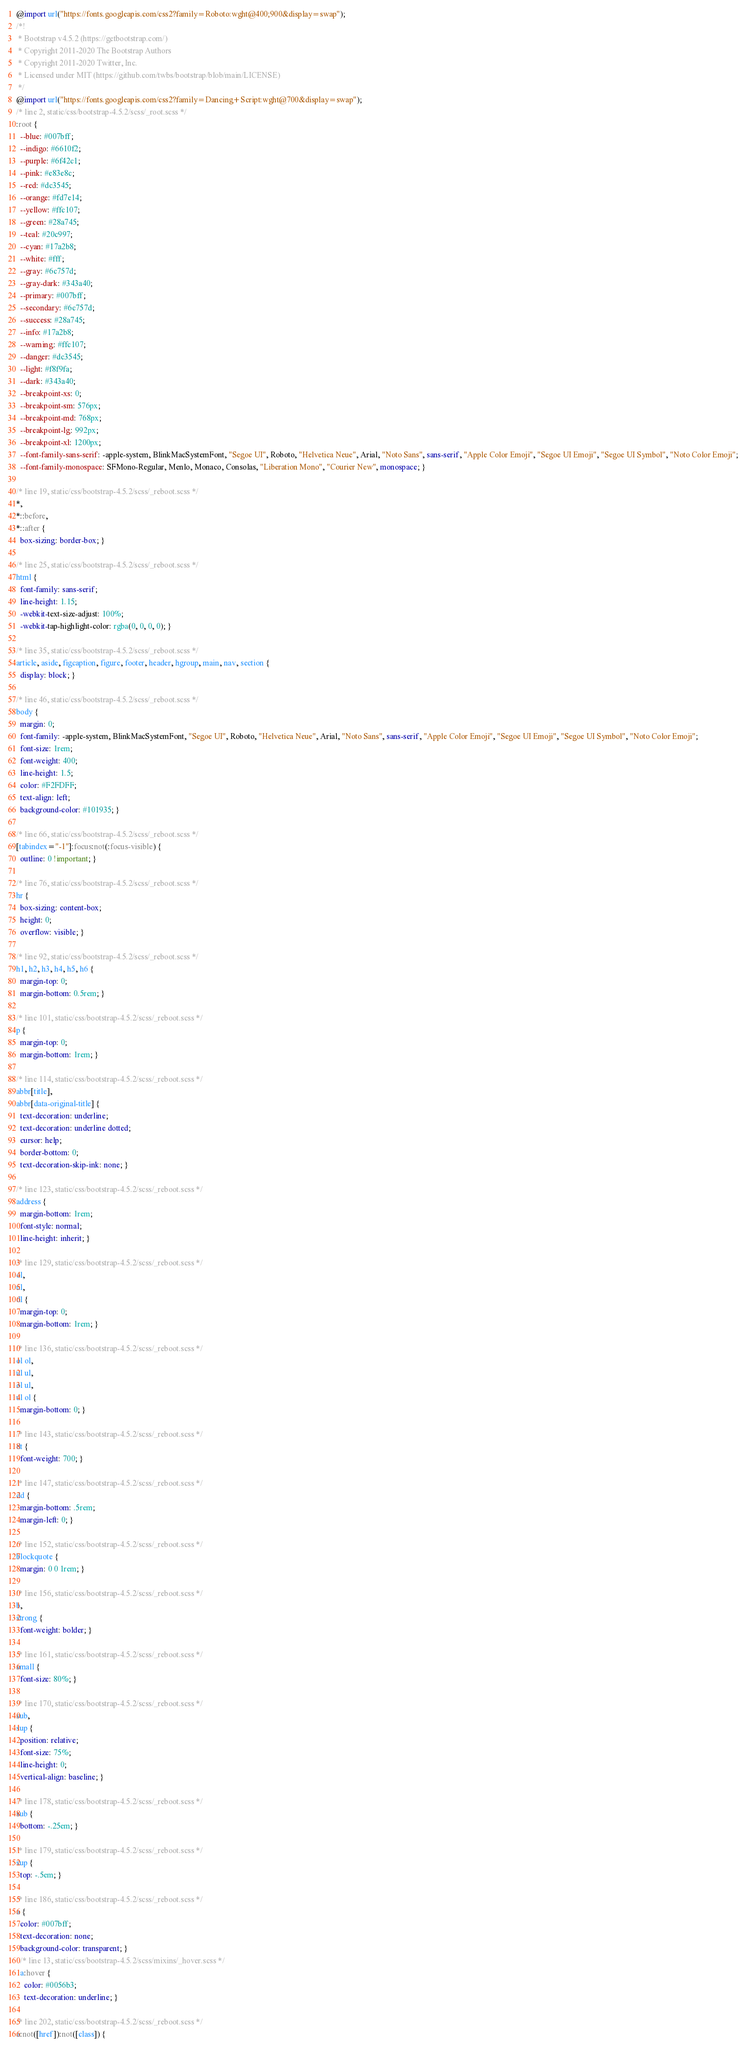<code> <loc_0><loc_0><loc_500><loc_500><_CSS_>@import url("https://fonts.googleapis.com/css2?family=Roboto:wght@400;900&display=swap");
/*!
 * Bootstrap v4.5.2 (https://getbootstrap.com/)
 * Copyright 2011-2020 The Bootstrap Authors
 * Copyright 2011-2020 Twitter, Inc.
 * Licensed under MIT (https://github.com/twbs/bootstrap/blob/main/LICENSE)
 */
@import url("https://fonts.googleapis.com/css2?family=Dancing+Script:wght@700&display=swap");
/* line 2, static/css/bootstrap-4.5.2/scss/_root.scss */
:root {
  --blue: #007bff;
  --indigo: #6610f2;
  --purple: #6f42c1;
  --pink: #e83e8c;
  --red: #dc3545;
  --orange: #fd7e14;
  --yellow: #ffc107;
  --green: #28a745;
  --teal: #20c997;
  --cyan: #17a2b8;
  --white: #fff;
  --gray: #6c757d;
  --gray-dark: #343a40;
  --primary: #007bff;
  --secondary: #6c757d;
  --success: #28a745;
  --info: #17a2b8;
  --warning: #ffc107;
  --danger: #dc3545;
  --light: #f8f9fa;
  --dark: #343a40;
  --breakpoint-xs: 0;
  --breakpoint-sm: 576px;
  --breakpoint-md: 768px;
  --breakpoint-lg: 992px;
  --breakpoint-xl: 1200px;
  --font-family-sans-serif: -apple-system, BlinkMacSystemFont, "Segoe UI", Roboto, "Helvetica Neue", Arial, "Noto Sans", sans-serif, "Apple Color Emoji", "Segoe UI Emoji", "Segoe UI Symbol", "Noto Color Emoji";
  --font-family-monospace: SFMono-Regular, Menlo, Monaco, Consolas, "Liberation Mono", "Courier New", monospace; }

/* line 19, static/css/bootstrap-4.5.2/scss/_reboot.scss */
*,
*::before,
*::after {
  box-sizing: border-box; }

/* line 25, static/css/bootstrap-4.5.2/scss/_reboot.scss */
html {
  font-family: sans-serif;
  line-height: 1.15;
  -webkit-text-size-adjust: 100%;
  -webkit-tap-highlight-color: rgba(0, 0, 0, 0); }

/* line 35, static/css/bootstrap-4.5.2/scss/_reboot.scss */
article, aside, figcaption, figure, footer, header, hgroup, main, nav, section {
  display: block; }

/* line 46, static/css/bootstrap-4.5.2/scss/_reboot.scss */
body {
  margin: 0;
  font-family: -apple-system, BlinkMacSystemFont, "Segoe UI", Roboto, "Helvetica Neue", Arial, "Noto Sans", sans-serif, "Apple Color Emoji", "Segoe UI Emoji", "Segoe UI Symbol", "Noto Color Emoji";
  font-size: 1rem;
  font-weight: 400;
  line-height: 1.5;
  color: #F2FDFF;
  text-align: left;
  background-color: #101935; }

/* line 66, static/css/bootstrap-4.5.2/scss/_reboot.scss */
[tabindex="-1"]:focus:not(:focus-visible) {
  outline: 0 !important; }

/* line 76, static/css/bootstrap-4.5.2/scss/_reboot.scss */
hr {
  box-sizing: content-box;
  height: 0;
  overflow: visible; }

/* line 92, static/css/bootstrap-4.5.2/scss/_reboot.scss */
h1, h2, h3, h4, h5, h6 {
  margin-top: 0;
  margin-bottom: 0.5rem; }

/* line 101, static/css/bootstrap-4.5.2/scss/_reboot.scss */
p {
  margin-top: 0;
  margin-bottom: 1rem; }

/* line 114, static/css/bootstrap-4.5.2/scss/_reboot.scss */
abbr[title],
abbr[data-original-title] {
  text-decoration: underline;
  text-decoration: underline dotted;
  cursor: help;
  border-bottom: 0;
  text-decoration-skip-ink: none; }

/* line 123, static/css/bootstrap-4.5.2/scss/_reboot.scss */
address {
  margin-bottom: 1rem;
  font-style: normal;
  line-height: inherit; }

/* line 129, static/css/bootstrap-4.5.2/scss/_reboot.scss */
ol,
ul,
dl {
  margin-top: 0;
  margin-bottom: 1rem; }

/* line 136, static/css/bootstrap-4.5.2/scss/_reboot.scss */
ol ol,
ul ul,
ol ul,
ul ol {
  margin-bottom: 0; }

/* line 143, static/css/bootstrap-4.5.2/scss/_reboot.scss */
dt {
  font-weight: 700; }

/* line 147, static/css/bootstrap-4.5.2/scss/_reboot.scss */
dd {
  margin-bottom: .5rem;
  margin-left: 0; }

/* line 152, static/css/bootstrap-4.5.2/scss/_reboot.scss */
blockquote {
  margin: 0 0 1rem; }

/* line 156, static/css/bootstrap-4.5.2/scss/_reboot.scss */
b,
strong {
  font-weight: bolder; }

/* line 161, static/css/bootstrap-4.5.2/scss/_reboot.scss */
small {
  font-size: 80%; }

/* line 170, static/css/bootstrap-4.5.2/scss/_reboot.scss */
sub,
sup {
  position: relative;
  font-size: 75%;
  line-height: 0;
  vertical-align: baseline; }

/* line 178, static/css/bootstrap-4.5.2/scss/_reboot.scss */
sub {
  bottom: -.25em; }

/* line 179, static/css/bootstrap-4.5.2/scss/_reboot.scss */
sup {
  top: -.5em; }

/* line 186, static/css/bootstrap-4.5.2/scss/_reboot.scss */
a {
  color: #007bff;
  text-decoration: none;
  background-color: transparent; }
  /* line 13, static/css/bootstrap-4.5.2/scss/mixins/_hover.scss */
  a:hover {
    color: #0056b3;
    text-decoration: underline; }

/* line 202, static/css/bootstrap-4.5.2/scss/_reboot.scss */
a:not([href]):not([class]) {</code> 